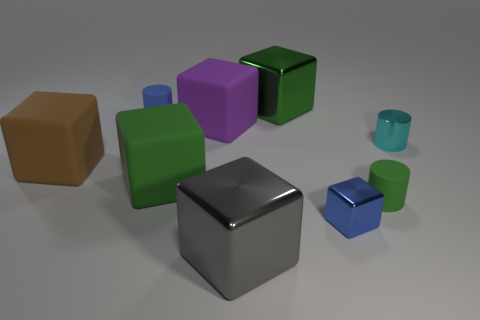What is the large gray cube made of?
Provide a succinct answer. Metal. There is a small object that is the same color as the tiny block; what shape is it?
Provide a short and direct response. Cylinder. Is the large brown cube that is to the left of the tiny blue cube made of the same material as the large thing on the right side of the gray object?
Your answer should be very brief. No. Is the color of the tiny matte object that is to the left of the small green matte object the same as the tiny metallic cube that is in front of the large purple block?
Provide a succinct answer. Yes. There is a blue block that is the same size as the cyan metal cylinder; what material is it?
Offer a very short reply. Metal. How big is the blue thing that is left of the purple rubber block?
Provide a succinct answer. Small. What number of objects are both in front of the tiny cyan shiny thing and on the right side of the big green shiny object?
Make the answer very short. 2. The small thing that is on the left side of the big metallic object in front of the blue cylinder is made of what material?
Give a very brief answer. Rubber. There is a gray thing that is the same shape as the large brown object; what material is it?
Make the answer very short. Metal. Are there any tiny brown rubber balls?
Provide a short and direct response. No. 